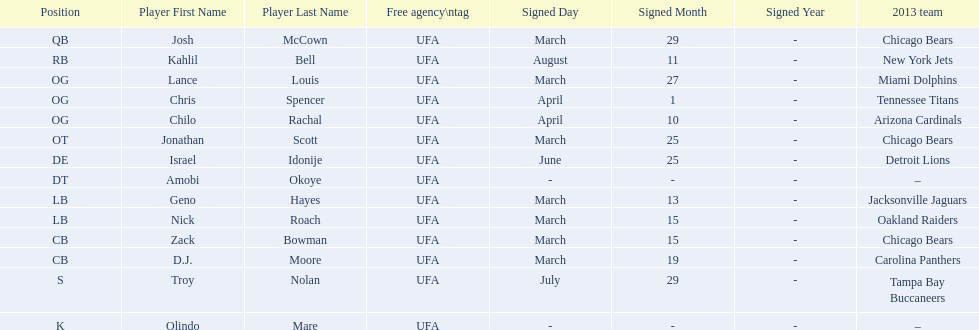Who are all of the players? Josh McCown, Kahlil Bell, Lance Louis, Chris Spencer, Chilo Rachal, Jonathan Scott, Israel Idonije, Amobi Okoye, Geno Hayes, Nick Roach, Zack Bowman, D. J. Moore, Troy Nolan, Olindo Mare. When were they signed? March 29, August 11, March 27, April 1, April 10, March 25, June 25, –, March 13, March 15, March 15, March 19, July 29, –. Along with nick roach, who else was signed on march 15? Zack Bowman. 